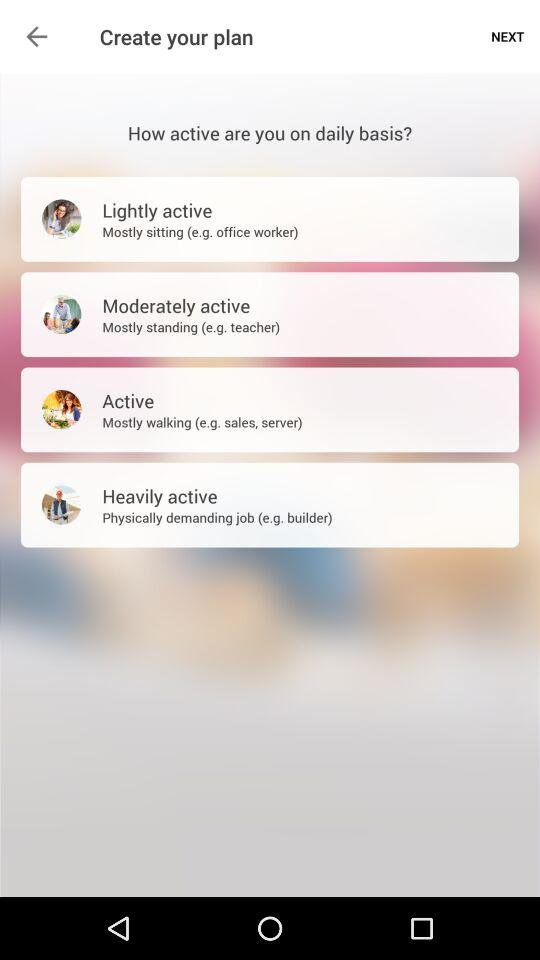Which option has the description "Physically demanding job"? The option that has the description "Physically demanding job" is "Heavily active". 